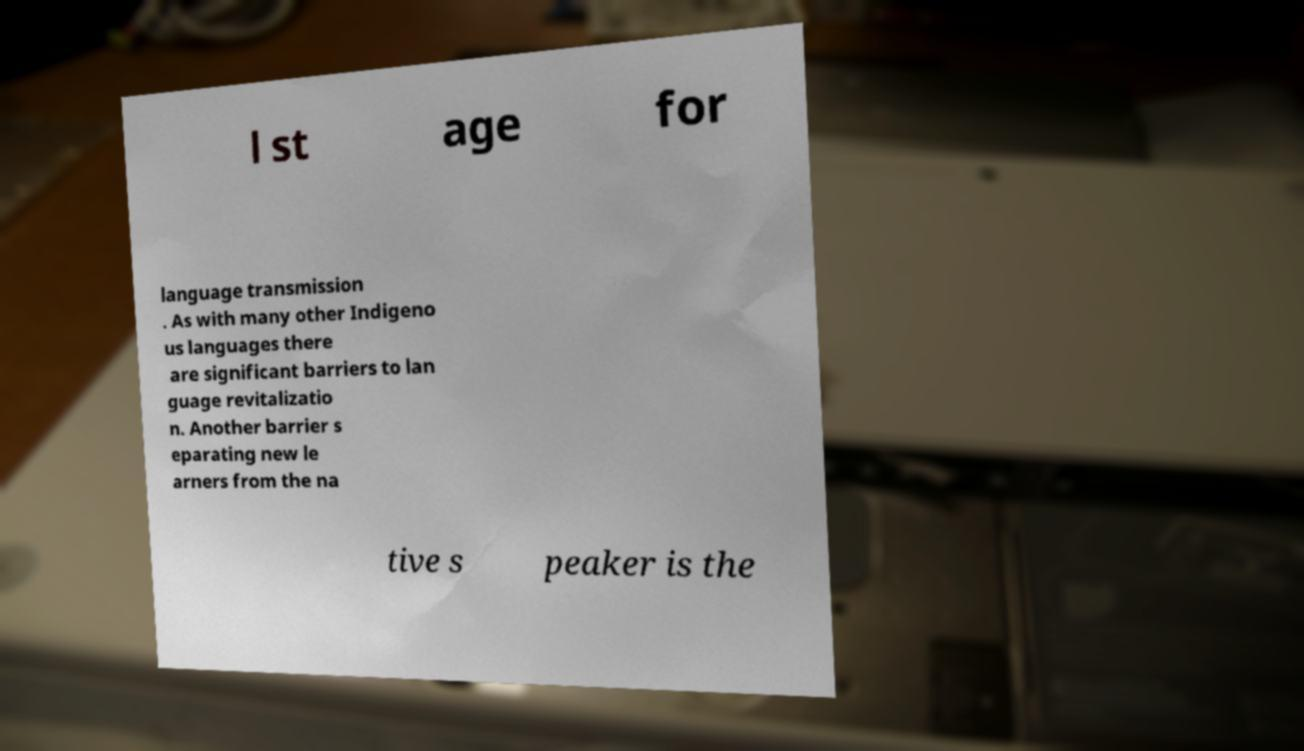Please identify and transcribe the text found in this image. l st age for language transmission . As with many other Indigeno us languages there are significant barriers to lan guage revitalizatio n. Another barrier s eparating new le arners from the na tive s peaker is the 